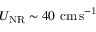Convert formula to latex. <formula><loc_0><loc_0><loc_500><loc_500>U _ { N R } \sim 4 0 c m \, s ^ { - 1 }</formula> 